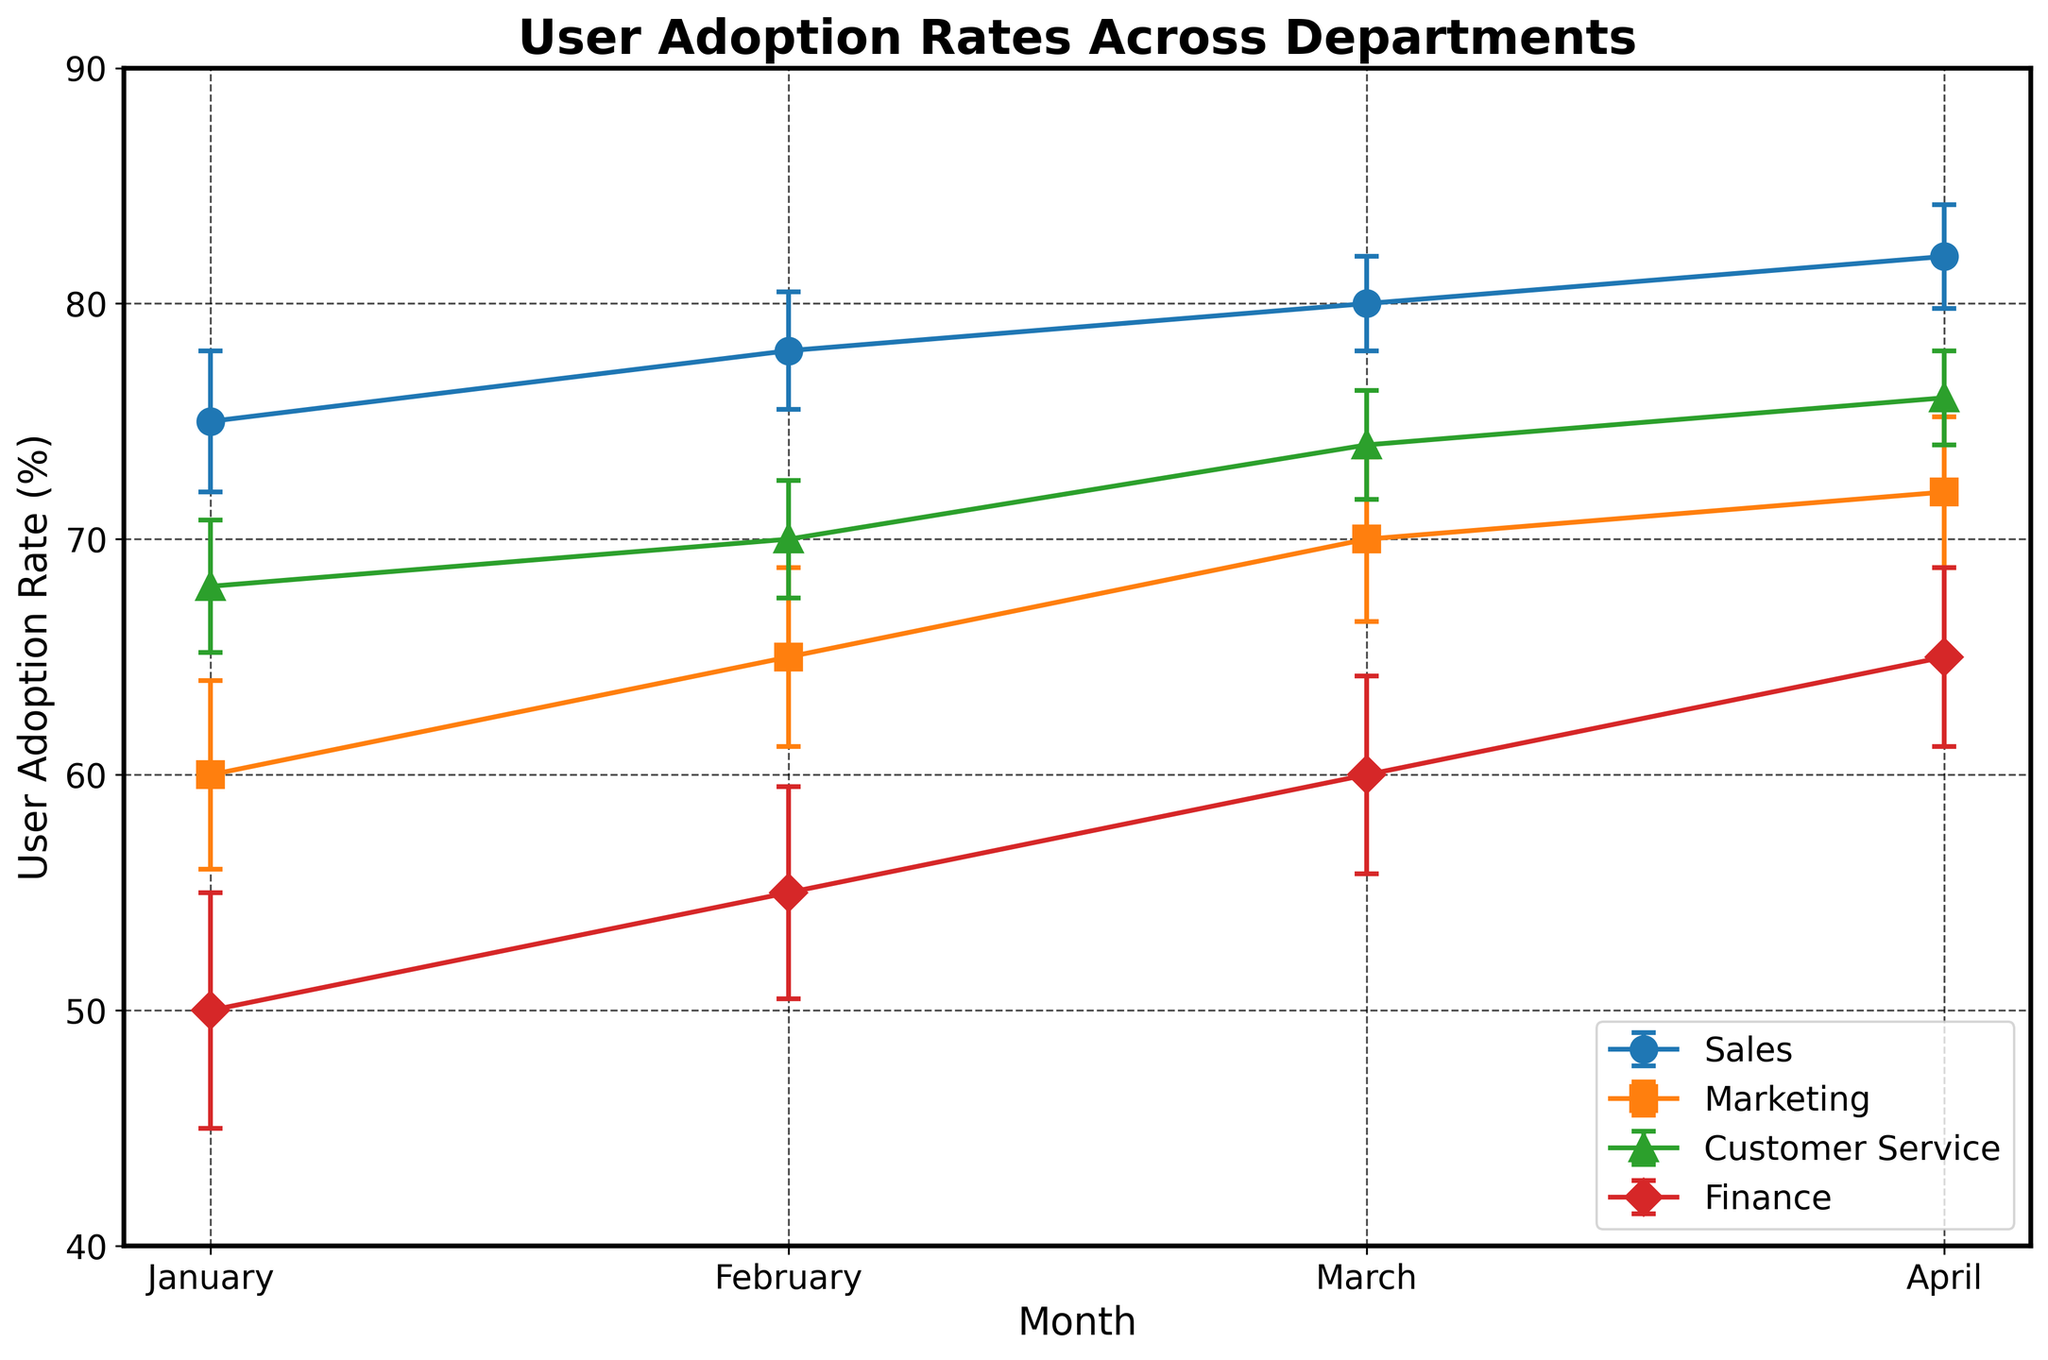What is the title of the plot? The title of the plot is located at the top of the figure and is clearly marked in bold.
Answer: User Adoption Rates Across Departments How many months are displayed on the x-axis? By counting the unique markers along the x-axis, we can see four distinct months displayed: January, February, March, and April.
Answer: 4 Which department has the highest user adoption rate in April? By looking at the highest points on the April data, it is clear that the Sales department has the highest adoption rate, at 82%.
Answer: Sales What is the error margin for the Marketing department in February? Referring to the error bars for the Marketing department in February, we see an error margin of 3.8%.
Answer: 3.8 Which department shows the most significant increase in user adoption rate from January to April? By calculating the difference between April and January user adoption rates for each department: Sales (82-75=7%), Marketing (72-60=12%), Customer Service (76-68=8%), and Finance (65-50=15%), we see that the Finance department has the most significant increase.
Answer: Finance What is the user adoption rate for the Customer Service department in March and its error margin? Looking at the figure, in March, the Customer Service department has a user adoption rate of 74% with an error margin of 2.3%.
Answer: 74%, 2.3% Compare the user adoption rates between Marketing and Finance in January. The Marketing department has a user adoption rate of 60% in January, while the Finance department has a user adoption rate of 50%. Therefore, Marketing has a higher rate.
Answer: Marketing What is the trend in user adoption rates for the Sales department over the months? Observing the Sales department's data points, the user adoption rates steadily increase from January (75%) to April (82%). This indicates a consistent upward trend.
Answer: Upward During which month does the Customer Service department have the smallest error margin? From the plot, in April, the Customer Service department has the smallest error margin at 2%.
Answer: April 